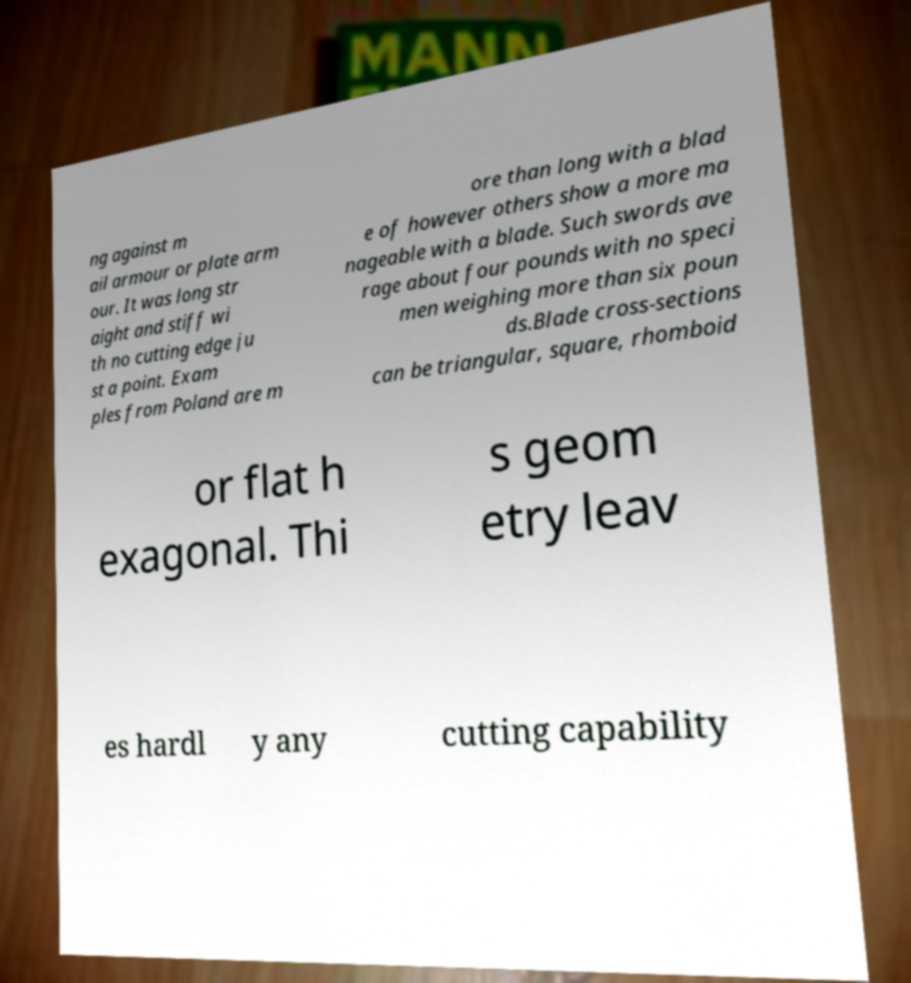For documentation purposes, I need the text within this image transcribed. Could you provide that? ng against m ail armour or plate arm our. It was long str aight and stiff wi th no cutting edge ju st a point. Exam ples from Poland are m ore than long with a blad e of however others show a more ma nageable with a blade. Such swords ave rage about four pounds with no speci men weighing more than six poun ds.Blade cross-sections can be triangular, square, rhomboid or flat h exagonal. Thi s geom etry leav es hardl y any cutting capability 